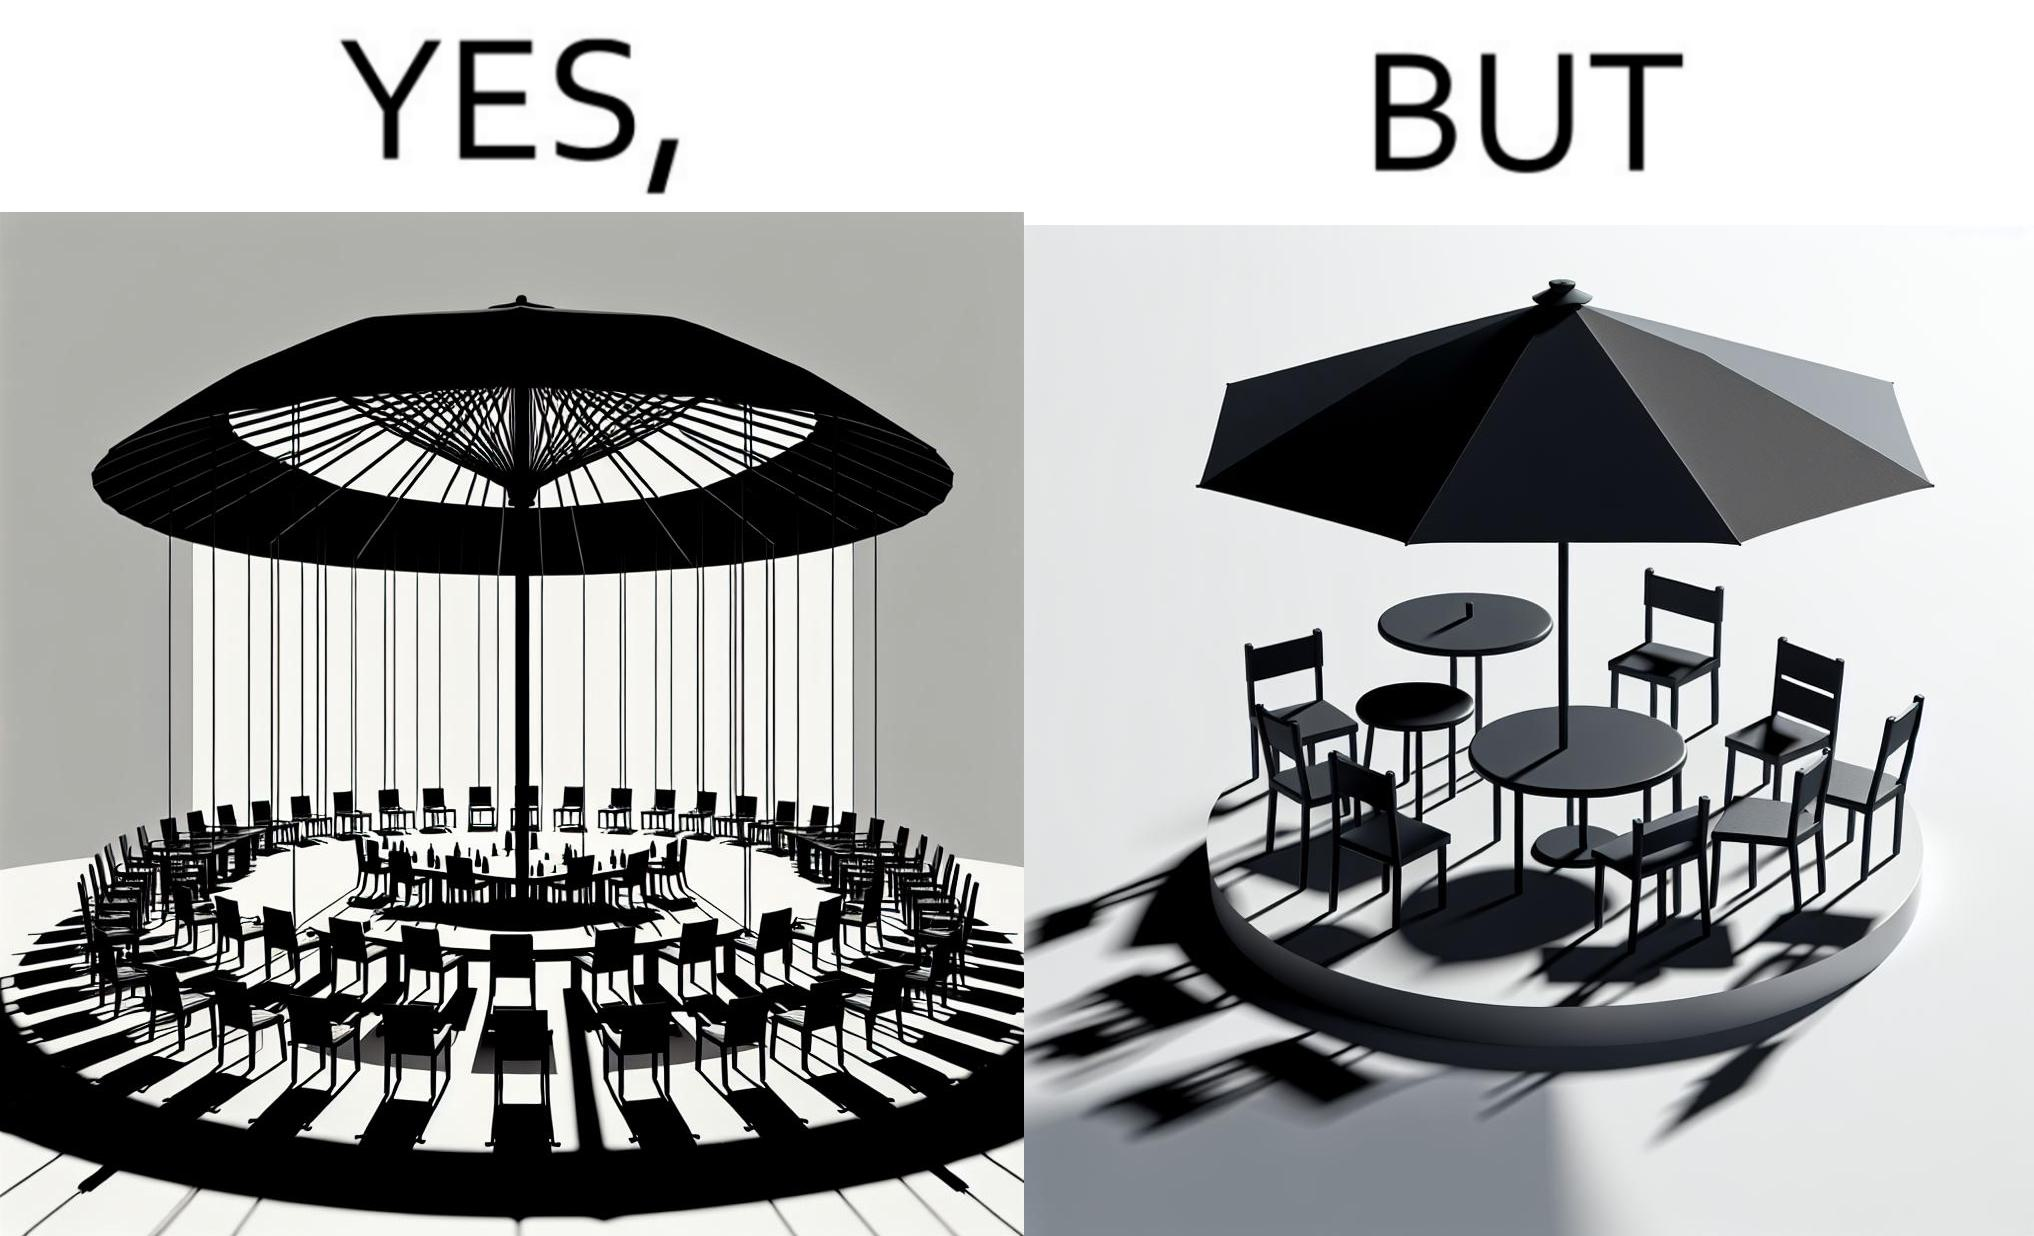Describe what you see in the left and right parts of this image. In the left part of the image: Chairs surrounding a table under a large umbrella. In the right part of the image: Chairs surrounding a table under a large umbrella, with the shadow of the umbrella appearing on the side. 